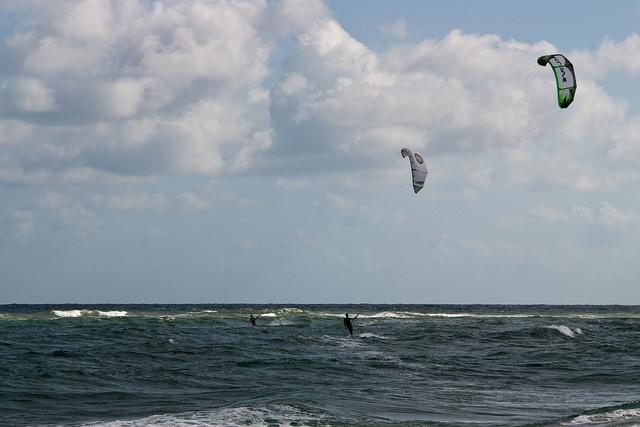How many sails are in the sky?
Write a very short answer. 2. Is the sky clear?
Short answer required. No. Are there mountains in the background?
Answer briefly. No. Do you see clouds?
Be succinct. Yes. What can be seen in the distance?
Answer briefly. Clouds. Are these parachutes?
Keep it brief. No. What is in the air?
Give a very brief answer. Kites. Is the water calm?
Write a very short answer. No. 